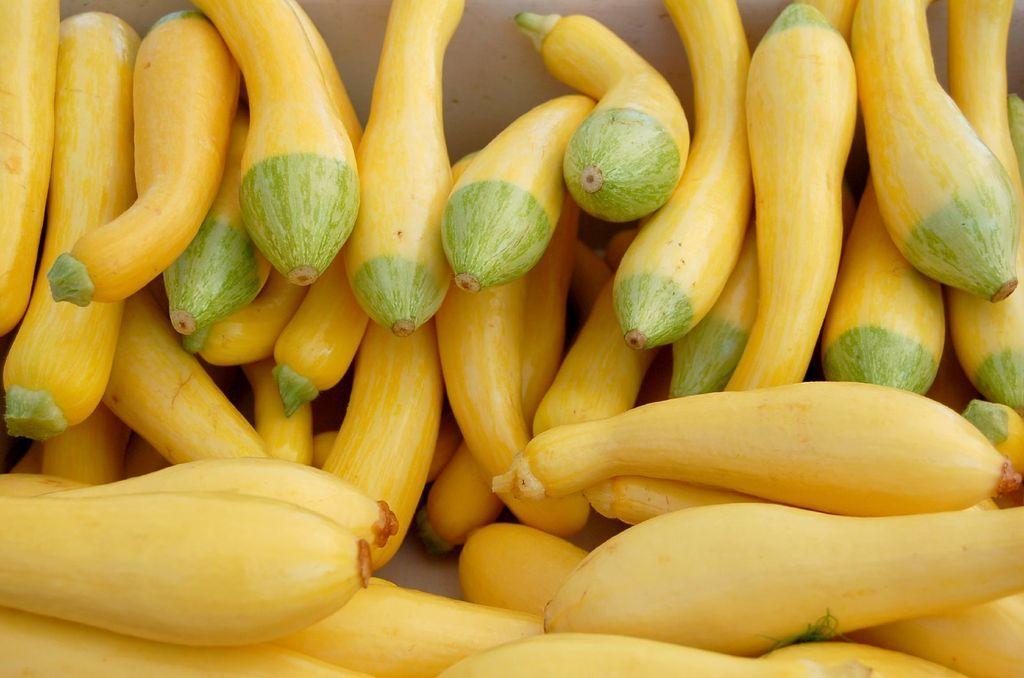How would you summarize this image in a sentence or two? In this image we can see there are vegetables. 